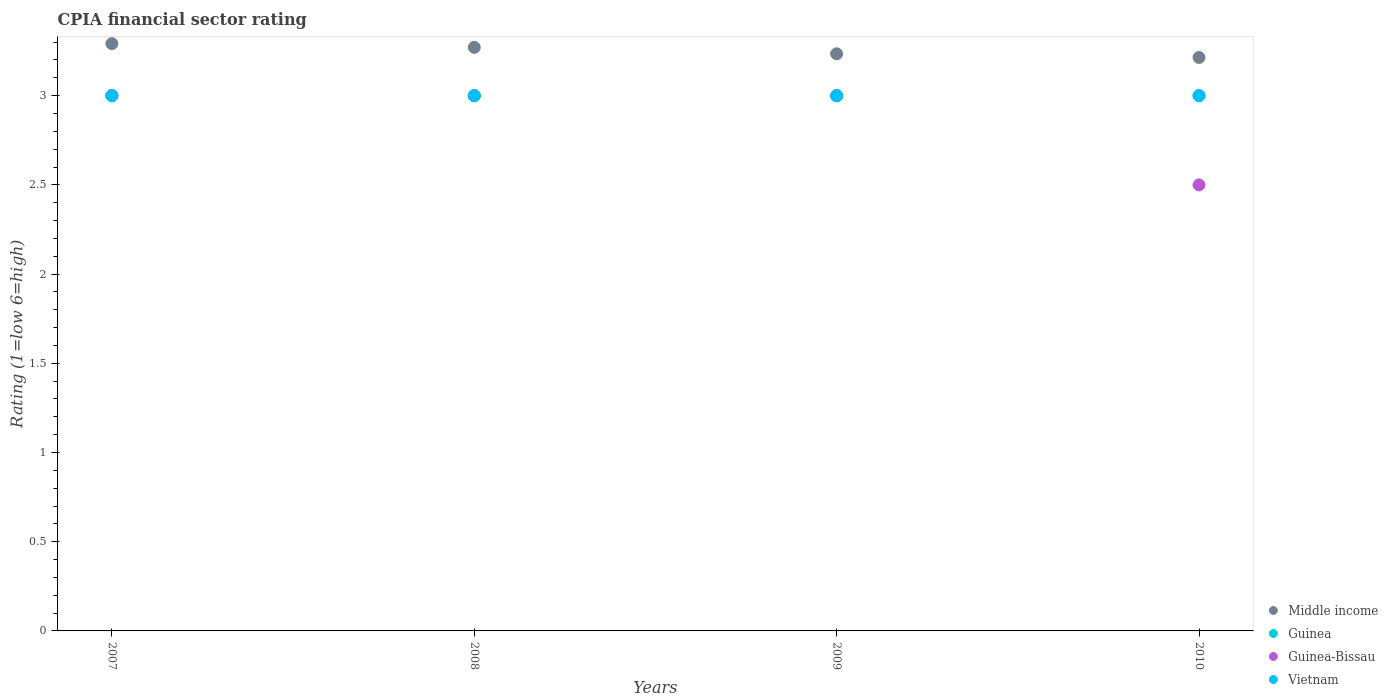How many different coloured dotlines are there?
Offer a terse response. 4. Is the number of dotlines equal to the number of legend labels?
Offer a terse response. Yes. What is the CPIA rating in Guinea in 2007?
Offer a terse response. 3. Across all years, what is the minimum CPIA rating in Guinea?
Offer a terse response. 3. In which year was the CPIA rating in Vietnam maximum?
Keep it short and to the point. 2007. In which year was the CPIA rating in Vietnam minimum?
Offer a very short reply. 2007. What is the total CPIA rating in Vietnam in the graph?
Offer a very short reply. 12. What is the difference between the CPIA rating in Guinea-Bissau in 2007 and that in 2008?
Provide a short and direct response. 0. What is the difference between the CPIA rating in Vietnam in 2009 and the CPIA rating in Middle income in 2010?
Ensure brevity in your answer.  -0.21. What is the average CPIA rating in Guinea-Bissau per year?
Offer a very short reply. 2.88. In the year 2010, what is the difference between the CPIA rating in Guinea and CPIA rating in Guinea-Bissau?
Keep it short and to the point. 0.5. In how many years, is the CPIA rating in Vietnam greater than 0.30000000000000004?
Your answer should be compact. 4. What is the ratio of the CPIA rating in Middle income in 2008 to that in 2009?
Provide a short and direct response. 1.01. Is the difference between the CPIA rating in Guinea in 2007 and 2009 greater than the difference between the CPIA rating in Guinea-Bissau in 2007 and 2009?
Offer a very short reply. No. What is the difference between the highest and the lowest CPIA rating in Vietnam?
Keep it short and to the point. 0. Is it the case that in every year, the sum of the CPIA rating in Guinea-Bissau and CPIA rating in Middle income  is greater than the sum of CPIA rating in Guinea and CPIA rating in Vietnam?
Keep it short and to the point. No. Is it the case that in every year, the sum of the CPIA rating in Vietnam and CPIA rating in Guinea-Bissau  is greater than the CPIA rating in Middle income?
Offer a terse response. Yes. Does the CPIA rating in Middle income monotonically increase over the years?
Your answer should be compact. No. Is the CPIA rating in Guinea-Bissau strictly greater than the CPIA rating in Vietnam over the years?
Keep it short and to the point. No. Is the CPIA rating in Guinea-Bissau strictly less than the CPIA rating in Guinea over the years?
Your answer should be compact. No. How many dotlines are there?
Provide a succinct answer. 4. How many years are there in the graph?
Your answer should be very brief. 4. Are the values on the major ticks of Y-axis written in scientific E-notation?
Your answer should be compact. No. Does the graph contain any zero values?
Ensure brevity in your answer.  No. How many legend labels are there?
Your answer should be very brief. 4. What is the title of the graph?
Provide a succinct answer. CPIA financial sector rating. Does "Belgium" appear as one of the legend labels in the graph?
Ensure brevity in your answer.  No. What is the label or title of the X-axis?
Make the answer very short. Years. What is the label or title of the Y-axis?
Offer a very short reply. Rating (1=low 6=high). What is the Rating (1=low 6=high) of Middle income in 2007?
Ensure brevity in your answer.  3.29. What is the Rating (1=low 6=high) in Vietnam in 2007?
Ensure brevity in your answer.  3. What is the Rating (1=low 6=high) in Middle income in 2008?
Make the answer very short. 3.27. What is the Rating (1=low 6=high) in Guinea in 2008?
Make the answer very short. 3. What is the Rating (1=low 6=high) in Guinea-Bissau in 2008?
Offer a very short reply. 3. What is the Rating (1=low 6=high) of Middle income in 2009?
Keep it short and to the point. 3.23. What is the Rating (1=low 6=high) of Guinea-Bissau in 2009?
Make the answer very short. 3. What is the Rating (1=low 6=high) of Vietnam in 2009?
Offer a very short reply. 3. What is the Rating (1=low 6=high) of Middle income in 2010?
Offer a very short reply. 3.21. Across all years, what is the maximum Rating (1=low 6=high) of Middle income?
Your answer should be compact. 3.29. Across all years, what is the maximum Rating (1=low 6=high) of Guinea?
Your answer should be compact. 3. Across all years, what is the maximum Rating (1=low 6=high) in Guinea-Bissau?
Provide a short and direct response. 3. Across all years, what is the minimum Rating (1=low 6=high) of Middle income?
Make the answer very short. 3.21. Across all years, what is the minimum Rating (1=low 6=high) of Guinea?
Provide a short and direct response. 3. Across all years, what is the minimum Rating (1=low 6=high) in Guinea-Bissau?
Offer a very short reply. 2.5. Across all years, what is the minimum Rating (1=low 6=high) in Vietnam?
Ensure brevity in your answer.  3. What is the total Rating (1=low 6=high) in Middle income in the graph?
Provide a succinct answer. 13.01. What is the total Rating (1=low 6=high) of Guinea-Bissau in the graph?
Your answer should be compact. 11.5. What is the total Rating (1=low 6=high) in Vietnam in the graph?
Provide a succinct answer. 12. What is the difference between the Rating (1=low 6=high) of Middle income in 2007 and that in 2008?
Your response must be concise. 0.02. What is the difference between the Rating (1=low 6=high) in Guinea in 2007 and that in 2008?
Your answer should be very brief. 0. What is the difference between the Rating (1=low 6=high) of Vietnam in 2007 and that in 2008?
Ensure brevity in your answer.  0. What is the difference between the Rating (1=low 6=high) of Middle income in 2007 and that in 2009?
Make the answer very short. 0.06. What is the difference between the Rating (1=low 6=high) in Guinea-Bissau in 2007 and that in 2009?
Provide a succinct answer. 0. What is the difference between the Rating (1=low 6=high) in Vietnam in 2007 and that in 2009?
Provide a short and direct response. 0. What is the difference between the Rating (1=low 6=high) of Middle income in 2007 and that in 2010?
Keep it short and to the point. 0.08. What is the difference between the Rating (1=low 6=high) in Guinea in 2007 and that in 2010?
Your answer should be very brief. 0. What is the difference between the Rating (1=low 6=high) of Guinea-Bissau in 2007 and that in 2010?
Offer a very short reply. 0.5. What is the difference between the Rating (1=low 6=high) of Middle income in 2008 and that in 2009?
Ensure brevity in your answer.  0.04. What is the difference between the Rating (1=low 6=high) of Guinea-Bissau in 2008 and that in 2009?
Make the answer very short. 0. What is the difference between the Rating (1=low 6=high) in Middle income in 2008 and that in 2010?
Make the answer very short. 0.06. What is the difference between the Rating (1=low 6=high) in Vietnam in 2008 and that in 2010?
Offer a very short reply. 0. What is the difference between the Rating (1=low 6=high) in Middle income in 2009 and that in 2010?
Your answer should be very brief. 0.02. What is the difference between the Rating (1=low 6=high) in Middle income in 2007 and the Rating (1=low 6=high) in Guinea in 2008?
Ensure brevity in your answer.  0.29. What is the difference between the Rating (1=low 6=high) in Middle income in 2007 and the Rating (1=low 6=high) in Guinea-Bissau in 2008?
Provide a succinct answer. 0.29. What is the difference between the Rating (1=low 6=high) in Middle income in 2007 and the Rating (1=low 6=high) in Vietnam in 2008?
Give a very brief answer. 0.29. What is the difference between the Rating (1=low 6=high) in Guinea in 2007 and the Rating (1=low 6=high) in Guinea-Bissau in 2008?
Keep it short and to the point. 0. What is the difference between the Rating (1=low 6=high) of Middle income in 2007 and the Rating (1=low 6=high) of Guinea in 2009?
Ensure brevity in your answer.  0.29. What is the difference between the Rating (1=low 6=high) of Middle income in 2007 and the Rating (1=low 6=high) of Guinea-Bissau in 2009?
Keep it short and to the point. 0.29. What is the difference between the Rating (1=low 6=high) of Middle income in 2007 and the Rating (1=low 6=high) of Vietnam in 2009?
Your answer should be compact. 0.29. What is the difference between the Rating (1=low 6=high) of Guinea in 2007 and the Rating (1=low 6=high) of Guinea-Bissau in 2009?
Give a very brief answer. 0. What is the difference between the Rating (1=low 6=high) of Middle income in 2007 and the Rating (1=low 6=high) of Guinea in 2010?
Your answer should be compact. 0.29. What is the difference between the Rating (1=low 6=high) in Middle income in 2007 and the Rating (1=low 6=high) in Guinea-Bissau in 2010?
Your answer should be compact. 0.79. What is the difference between the Rating (1=low 6=high) in Middle income in 2007 and the Rating (1=low 6=high) in Vietnam in 2010?
Provide a short and direct response. 0.29. What is the difference between the Rating (1=low 6=high) in Middle income in 2008 and the Rating (1=low 6=high) in Guinea in 2009?
Provide a succinct answer. 0.27. What is the difference between the Rating (1=low 6=high) of Middle income in 2008 and the Rating (1=low 6=high) of Guinea-Bissau in 2009?
Offer a terse response. 0.27. What is the difference between the Rating (1=low 6=high) of Middle income in 2008 and the Rating (1=low 6=high) of Vietnam in 2009?
Offer a very short reply. 0.27. What is the difference between the Rating (1=low 6=high) of Guinea in 2008 and the Rating (1=low 6=high) of Guinea-Bissau in 2009?
Your response must be concise. 0. What is the difference between the Rating (1=low 6=high) of Guinea in 2008 and the Rating (1=low 6=high) of Vietnam in 2009?
Give a very brief answer. 0. What is the difference between the Rating (1=low 6=high) in Middle income in 2008 and the Rating (1=low 6=high) in Guinea in 2010?
Keep it short and to the point. 0.27. What is the difference between the Rating (1=low 6=high) of Middle income in 2008 and the Rating (1=low 6=high) of Guinea-Bissau in 2010?
Your answer should be very brief. 0.77. What is the difference between the Rating (1=low 6=high) in Middle income in 2008 and the Rating (1=low 6=high) in Vietnam in 2010?
Provide a succinct answer. 0.27. What is the difference between the Rating (1=low 6=high) in Guinea in 2008 and the Rating (1=low 6=high) in Guinea-Bissau in 2010?
Offer a very short reply. 0.5. What is the difference between the Rating (1=low 6=high) of Guinea in 2008 and the Rating (1=low 6=high) of Vietnam in 2010?
Offer a terse response. 0. What is the difference between the Rating (1=low 6=high) in Middle income in 2009 and the Rating (1=low 6=high) in Guinea in 2010?
Offer a terse response. 0.23. What is the difference between the Rating (1=low 6=high) of Middle income in 2009 and the Rating (1=low 6=high) of Guinea-Bissau in 2010?
Your response must be concise. 0.73. What is the difference between the Rating (1=low 6=high) of Middle income in 2009 and the Rating (1=low 6=high) of Vietnam in 2010?
Provide a short and direct response. 0.23. What is the difference between the Rating (1=low 6=high) in Guinea-Bissau in 2009 and the Rating (1=low 6=high) in Vietnam in 2010?
Provide a short and direct response. 0. What is the average Rating (1=low 6=high) in Middle income per year?
Offer a very short reply. 3.25. What is the average Rating (1=low 6=high) of Guinea per year?
Offer a terse response. 3. What is the average Rating (1=low 6=high) of Guinea-Bissau per year?
Provide a short and direct response. 2.88. In the year 2007, what is the difference between the Rating (1=low 6=high) of Middle income and Rating (1=low 6=high) of Guinea?
Offer a very short reply. 0.29. In the year 2007, what is the difference between the Rating (1=low 6=high) of Middle income and Rating (1=low 6=high) of Guinea-Bissau?
Make the answer very short. 0.29. In the year 2007, what is the difference between the Rating (1=low 6=high) in Middle income and Rating (1=low 6=high) in Vietnam?
Your answer should be compact. 0.29. In the year 2007, what is the difference between the Rating (1=low 6=high) in Guinea-Bissau and Rating (1=low 6=high) in Vietnam?
Your answer should be compact. 0. In the year 2008, what is the difference between the Rating (1=low 6=high) in Middle income and Rating (1=low 6=high) in Guinea?
Your answer should be very brief. 0.27. In the year 2008, what is the difference between the Rating (1=low 6=high) of Middle income and Rating (1=low 6=high) of Guinea-Bissau?
Offer a terse response. 0.27. In the year 2008, what is the difference between the Rating (1=low 6=high) in Middle income and Rating (1=low 6=high) in Vietnam?
Ensure brevity in your answer.  0.27. In the year 2008, what is the difference between the Rating (1=low 6=high) of Guinea and Rating (1=low 6=high) of Guinea-Bissau?
Ensure brevity in your answer.  0. In the year 2009, what is the difference between the Rating (1=low 6=high) in Middle income and Rating (1=low 6=high) in Guinea?
Your answer should be very brief. 0.23. In the year 2009, what is the difference between the Rating (1=low 6=high) in Middle income and Rating (1=low 6=high) in Guinea-Bissau?
Provide a short and direct response. 0.23. In the year 2009, what is the difference between the Rating (1=low 6=high) in Middle income and Rating (1=low 6=high) in Vietnam?
Keep it short and to the point. 0.23. In the year 2010, what is the difference between the Rating (1=low 6=high) of Middle income and Rating (1=low 6=high) of Guinea?
Keep it short and to the point. 0.21. In the year 2010, what is the difference between the Rating (1=low 6=high) in Middle income and Rating (1=low 6=high) in Vietnam?
Keep it short and to the point. 0.21. In the year 2010, what is the difference between the Rating (1=low 6=high) of Guinea and Rating (1=low 6=high) of Vietnam?
Provide a short and direct response. 0. What is the ratio of the Rating (1=low 6=high) in Middle income in 2007 to that in 2008?
Your answer should be very brief. 1.01. What is the ratio of the Rating (1=low 6=high) in Middle income in 2007 to that in 2009?
Your response must be concise. 1.02. What is the ratio of the Rating (1=low 6=high) in Guinea-Bissau in 2007 to that in 2009?
Your response must be concise. 1. What is the ratio of the Rating (1=low 6=high) in Middle income in 2007 to that in 2010?
Ensure brevity in your answer.  1.02. What is the ratio of the Rating (1=low 6=high) of Guinea in 2007 to that in 2010?
Your response must be concise. 1. What is the ratio of the Rating (1=low 6=high) in Guinea-Bissau in 2007 to that in 2010?
Your response must be concise. 1.2. What is the ratio of the Rating (1=low 6=high) of Middle income in 2008 to that in 2009?
Ensure brevity in your answer.  1.01. What is the ratio of the Rating (1=low 6=high) of Guinea in 2008 to that in 2009?
Offer a very short reply. 1. What is the ratio of the Rating (1=low 6=high) in Guinea-Bissau in 2008 to that in 2009?
Your answer should be compact. 1. What is the ratio of the Rating (1=low 6=high) in Vietnam in 2008 to that in 2009?
Make the answer very short. 1. What is the ratio of the Rating (1=low 6=high) in Middle income in 2008 to that in 2010?
Give a very brief answer. 1.02. What is the ratio of the Rating (1=low 6=high) in Guinea in 2008 to that in 2010?
Your response must be concise. 1. What is the ratio of the Rating (1=low 6=high) of Guinea-Bissau in 2008 to that in 2010?
Give a very brief answer. 1.2. What is the ratio of the Rating (1=low 6=high) in Guinea-Bissau in 2009 to that in 2010?
Offer a very short reply. 1.2. What is the difference between the highest and the second highest Rating (1=low 6=high) of Middle income?
Provide a short and direct response. 0.02. What is the difference between the highest and the second highest Rating (1=low 6=high) in Guinea?
Your answer should be very brief. 0. What is the difference between the highest and the second highest Rating (1=low 6=high) in Guinea-Bissau?
Keep it short and to the point. 0. What is the difference between the highest and the lowest Rating (1=low 6=high) of Middle income?
Keep it short and to the point. 0.08. 